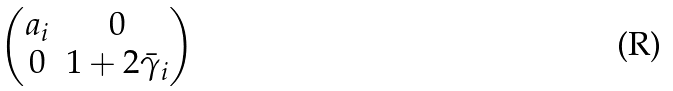<formula> <loc_0><loc_0><loc_500><loc_500>\begin{pmatrix} a _ { i } & 0 \\ 0 & 1 + 2 \bar { \gamma } _ { i } \end{pmatrix}</formula> 